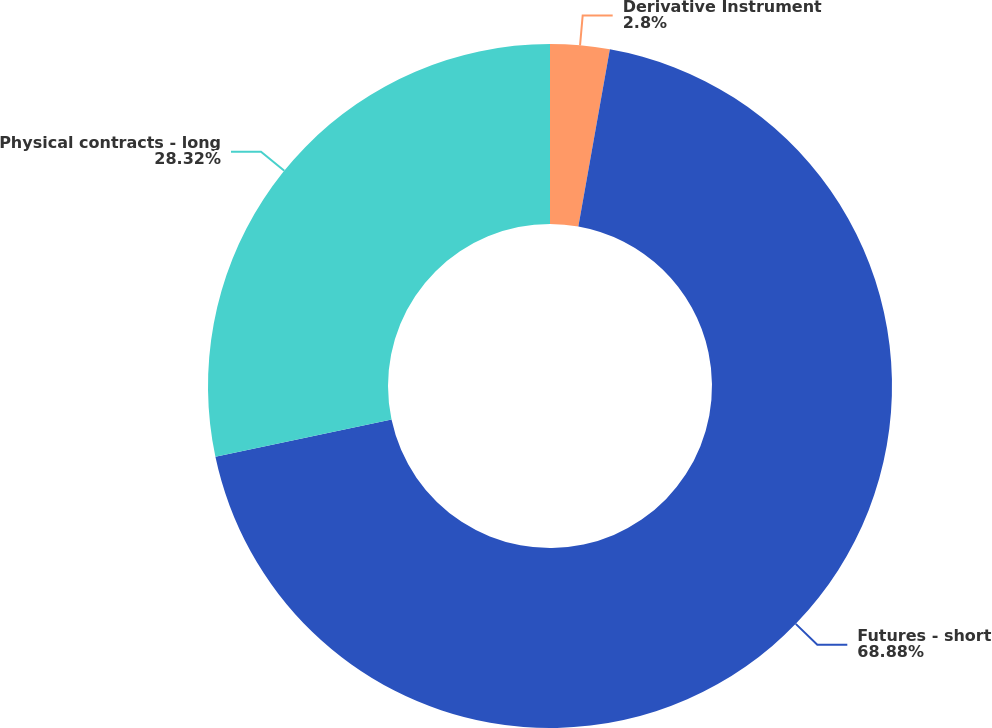Convert chart to OTSL. <chart><loc_0><loc_0><loc_500><loc_500><pie_chart><fcel>Derivative Instrument<fcel>Futures - short<fcel>Physical contracts - long<nl><fcel>2.8%<fcel>68.88%<fcel>28.32%<nl></chart> 